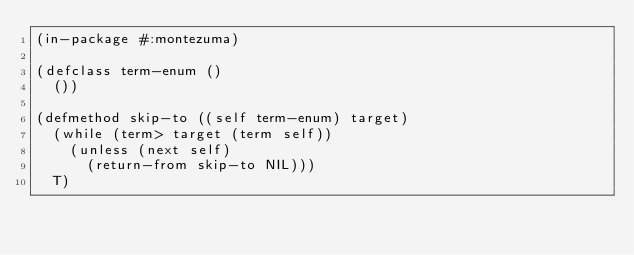<code> <loc_0><loc_0><loc_500><loc_500><_Lisp_>(in-package #:montezuma)

(defclass term-enum ()
  ())

(defmethod skip-to ((self term-enum) target)
  (while (term> target (term self))
    (unless (next self)
      (return-from skip-to NIL)))
  T)

  </code> 